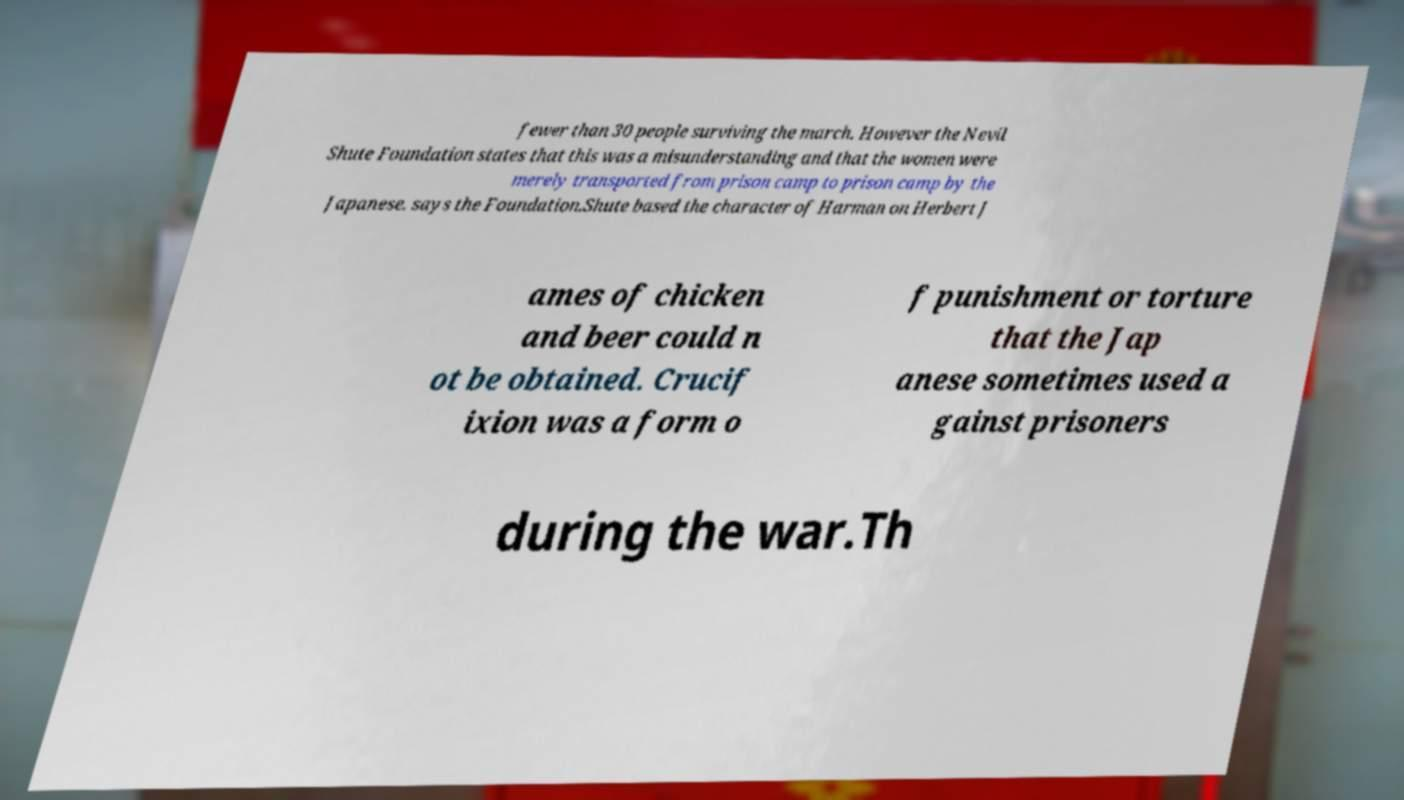For documentation purposes, I need the text within this image transcribed. Could you provide that? fewer than 30 people surviving the march. However the Nevil Shute Foundation states that this was a misunderstanding and that the women were merely transported from prison camp to prison camp by the Japanese. says the Foundation.Shute based the character of Harman on Herbert J ames of chicken and beer could n ot be obtained. Crucif ixion was a form o f punishment or torture that the Jap anese sometimes used a gainst prisoners during the war.Th 